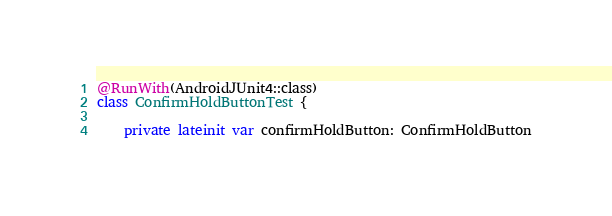<code> <loc_0><loc_0><loc_500><loc_500><_Kotlin_>@RunWith(AndroidJUnit4::class)
class ConfirmHoldButtonTest {

    private lateinit var confirmHoldButton: ConfirmHoldButton</code> 